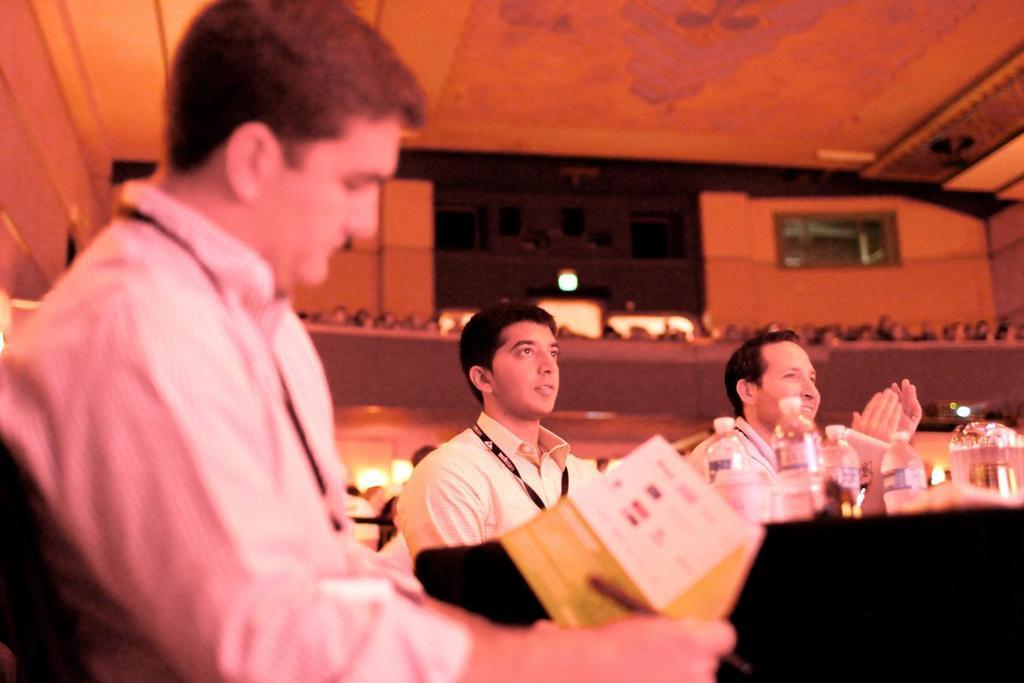In one or two sentences, can you explain what this image depicts? In this image we can see three men sitting behind the table. In addition to this we can see walls, disposal bottles, books and a window. 